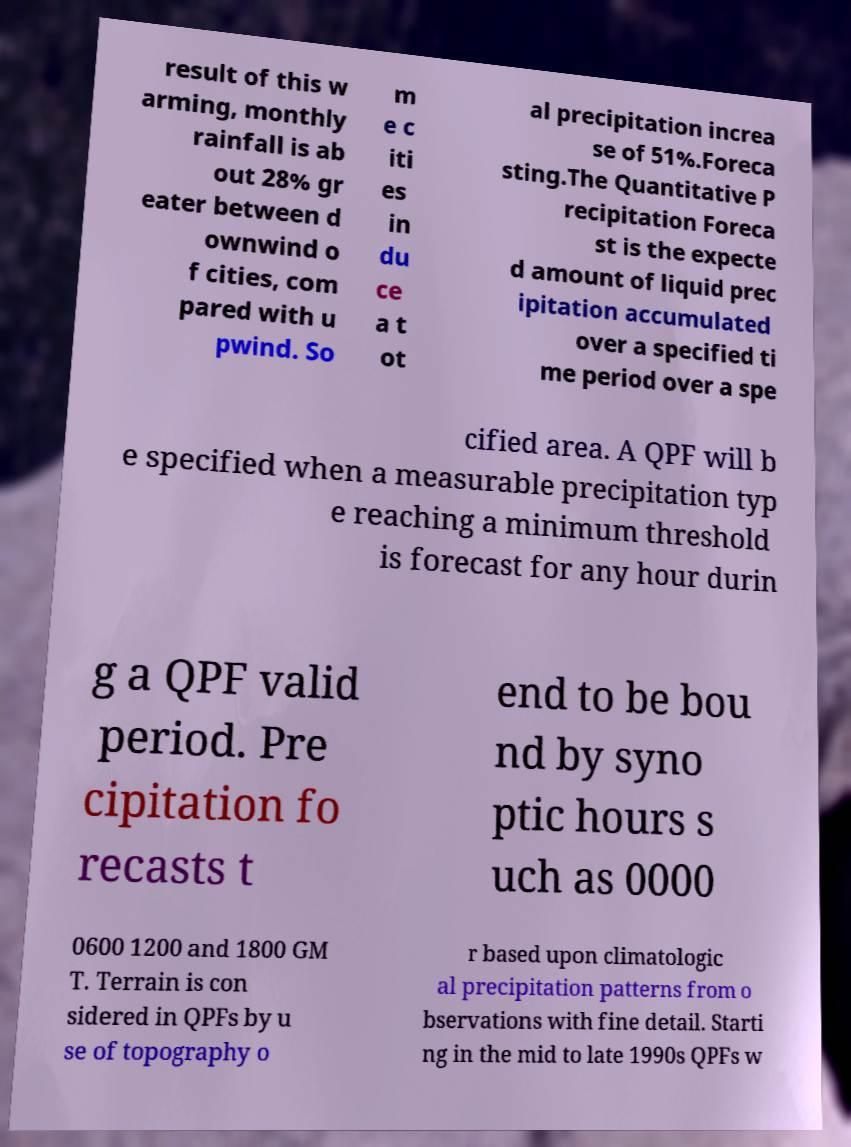Please read and relay the text visible in this image. What does it say? result of this w arming, monthly rainfall is ab out 28% gr eater between d ownwind o f cities, com pared with u pwind. So m e c iti es in du ce a t ot al precipitation increa se of 51%.Foreca sting.The Quantitative P recipitation Foreca st is the expecte d amount of liquid prec ipitation accumulated over a specified ti me period over a spe cified area. A QPF will b e specified when a measurable precipitation typ e reaching a minimum threshold is forecast for any hour durin g a QPF valid period. Pre cipitation fo recasts t end to be bou nd by syno ptic hours s uch as 0000 0600 1200 and 1800 GM T. Terrain is con sidered in QPFs by u se of topography o r based upon climatologic al precipitation patterns from o bservations with fine detail. Starti ng in the mid to late 1990s QPFs w 